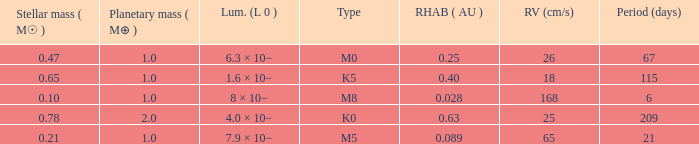What is the total stellar mass of the type m0? 0.47. 